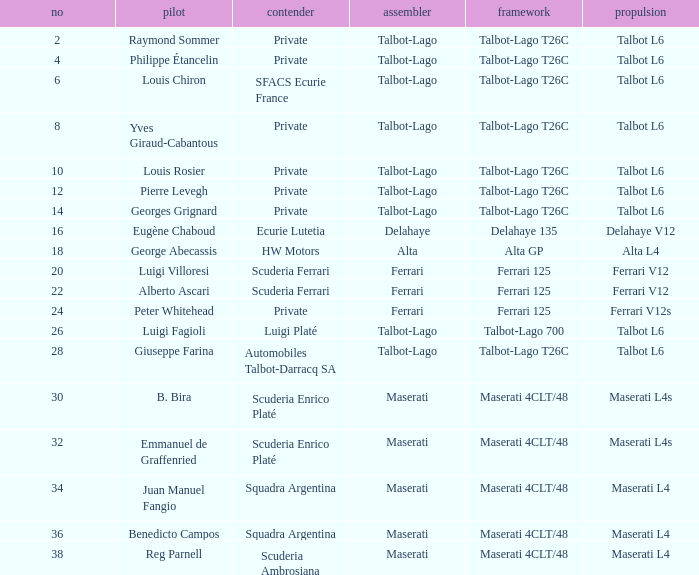Name the engine for ecurie lutetia Delahaye V12. 